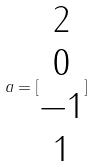<formula> <loc_0><loc_0><loc_500><loc_500>a = [ \begin{matrix} 2 \\ 0 \\ - 1 \\ 1 \end{matrix} ]</formula> 